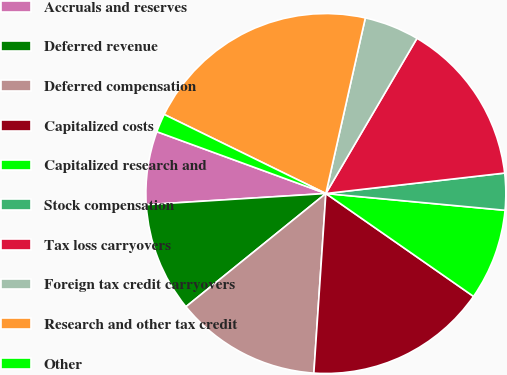Convert chart. <chart><loc_0><loc_0><loc_500><loc_500><pie_chart><fcel>Accruals and reserves<fcel>Deferred revenue<fcel>Deferred compensation<fcel>Capitalized costs<fcel>Capitalized research and<fcel>Stock compensation<fcel>Tax loss carryovers<fcel>Foreign tax credit carryovers<fcel>Research and other tax credit<fcel>Other<nl><fcel>6.57%<fcel>9.84%<fcel>13.11%<fcel>16.38%<fcel>8.2%<fcel>3.3%<fcel>14.74%<fcel>4.93%<fcel>21.28%<fcel>1.66%<nl></chart> 